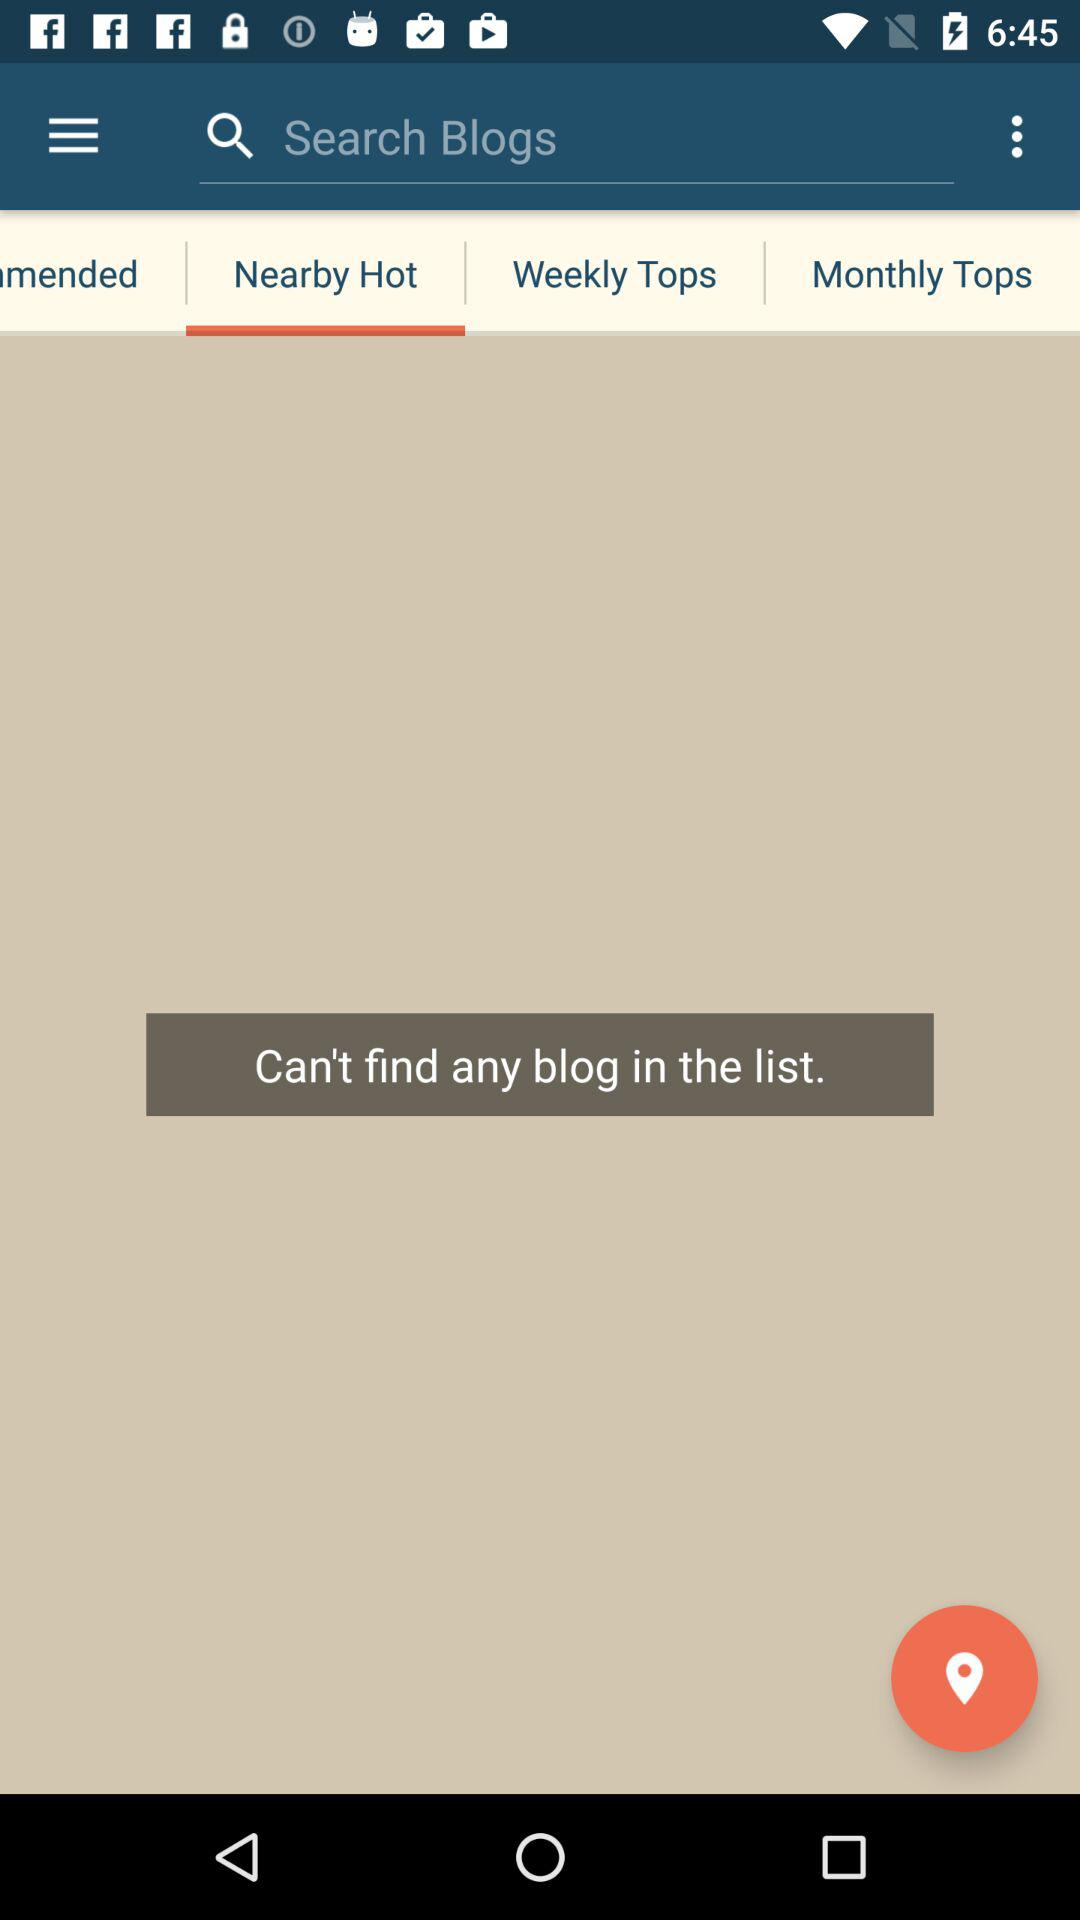Is there any blog in the list? There is no blog in the list. 